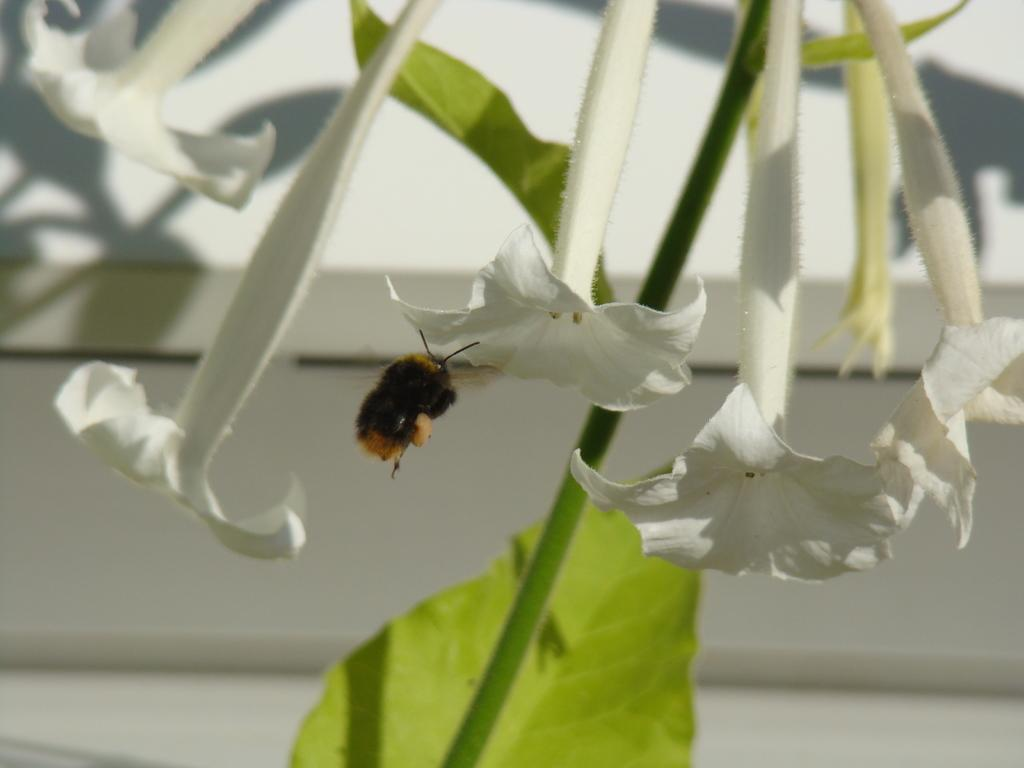What is the main subject of the image? There is a bee in the image. Where is the bee located in the image? The bee is sitting on a flower. What color are the flowers in the image? The flowers in the image are white-colored. What type of plant do the flowers belong to? The flowers are on plants. How would you describe the background of the image? The background of the image is slightly blurred. What type of soap is the bee using to clean itself in the image? There is no soap present in the image, and bees do not use soap to clean themselves. 